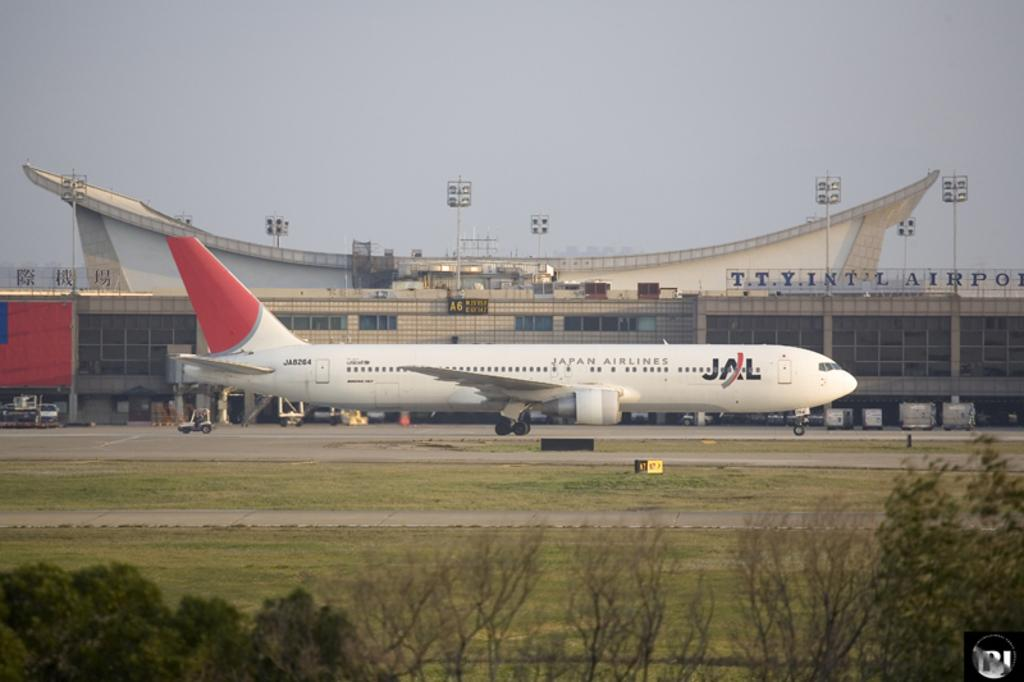<image>
Relay a brief, clear account of the picture shown. A Japan Airlines airplane om the tarmac of the T.Y. Int. Airport. 